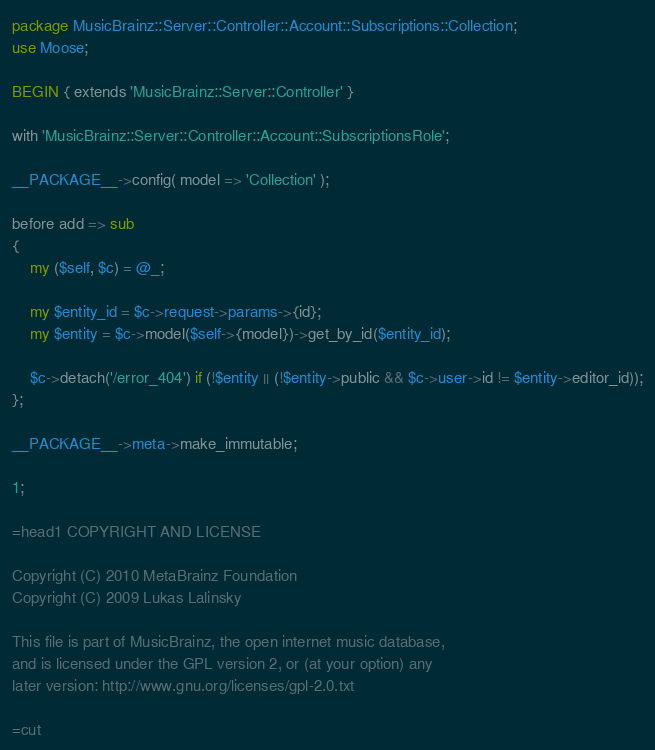Convert code to text. <code><loc_0><loc_0><loc_500><loc_500><_Perl_>package MusicBrainz::Server::Controller::Account::Subscriptions::Collection;
use Moose;

BEGIN { extends 'MusicBrainz::Server::Controller' }

with 'MusicBrainz::Server::Controller::Account::SubscriptionsRole';

__PACKAGE__->config( model => 'Collection' );

before add => sub
{
    my ($self, $c) = @_;

    my $entity_id = $c->request->params->{id};
    my $entity = $c->model($self->{model})->get_by_id($entity_id);

    $c->detach('/error_404') if (!$entity || (!$entity->public && $c->user->id != $entity->editor_id));
};

__PACKAGE__->meta->make_immutable;

1;

=head1 COPYRIGHT AND LICENSE

Copyright (C) 2010 MetaBrainz Foundation
Copyright (C) 2009 Lukas Lalinsky

This file is part of MusicBrainz, the open internet music database,
and is licensed under the GPL version 2, or (at your option) any
later version: http://www.gnu.org/licenses/gpl-2.0.txt

=cut
</code> 